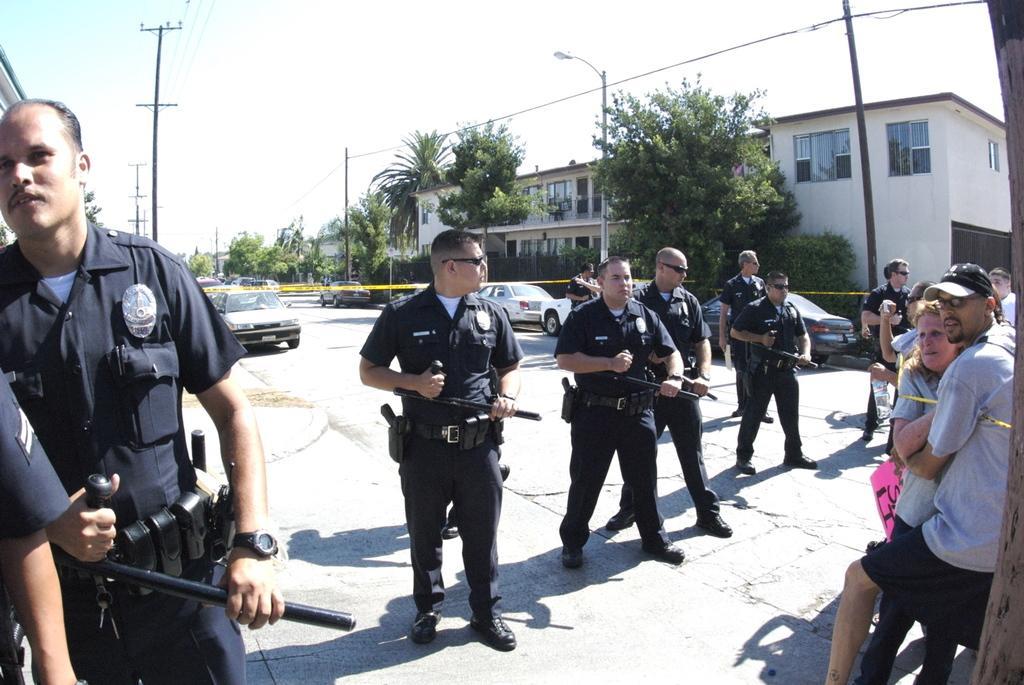Describe this image in one or two sentences. As we can see in the image there are group of people here and there, cars, current polls, street lamps, buildings and sky. 